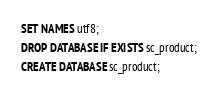Convert code to text. <code><loc_0><loc_0><loc_500><loc_500><_SQL_>SET NAMES utf8;
DROP DATABASE IF EXISTS sc_product;
CREATE DATABASE sc_product;
</code> 